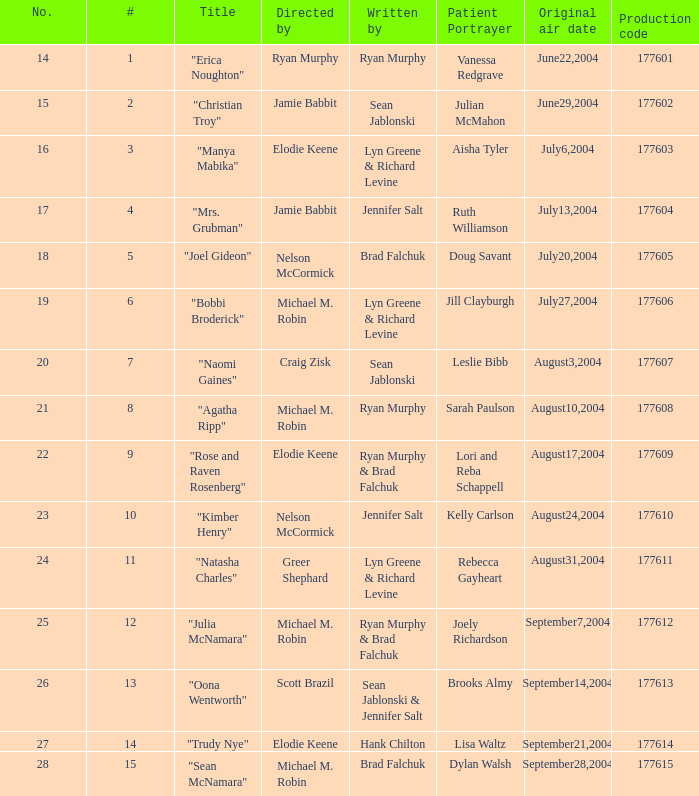Who created episode number 28? Brad Falchuk. 